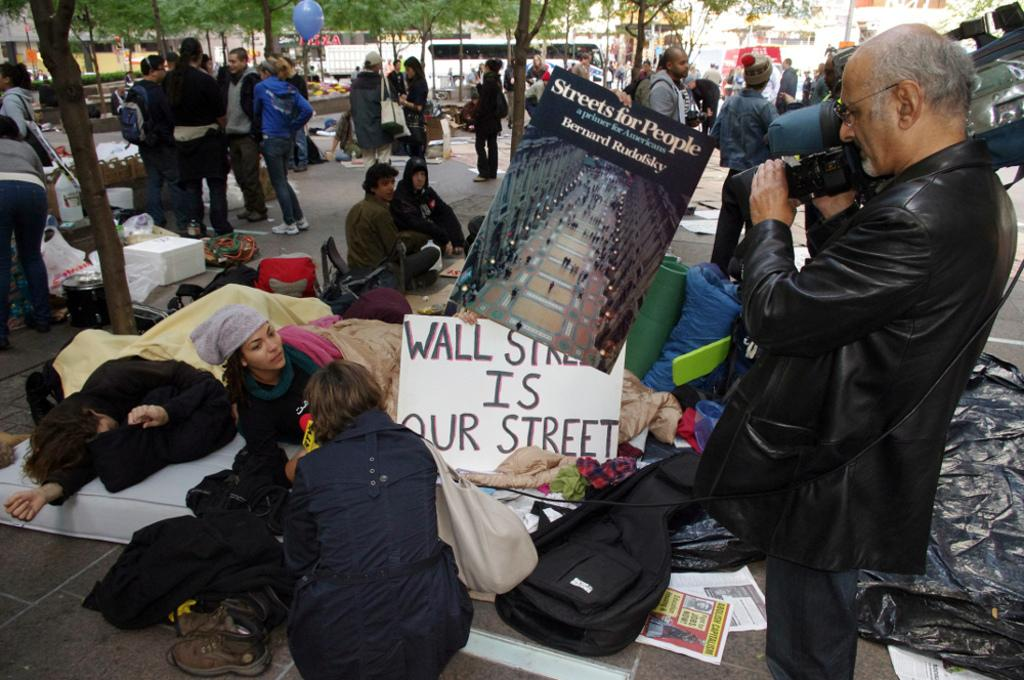How many people are in the image? There is a group of people in the image. What items can be seen in the image besides the people? There are bags, shoes, clothes, posters, a camera, a balloon, boxes, and vehicles in the image. What can be seen in the background of the image? There are buildings and trees in the background of the image. How much money is being exchanged between the people in the image? There is no indication of money or any exchange of money in the image. What type of fowl can be seen in the image? There are no fowl present in the image. 